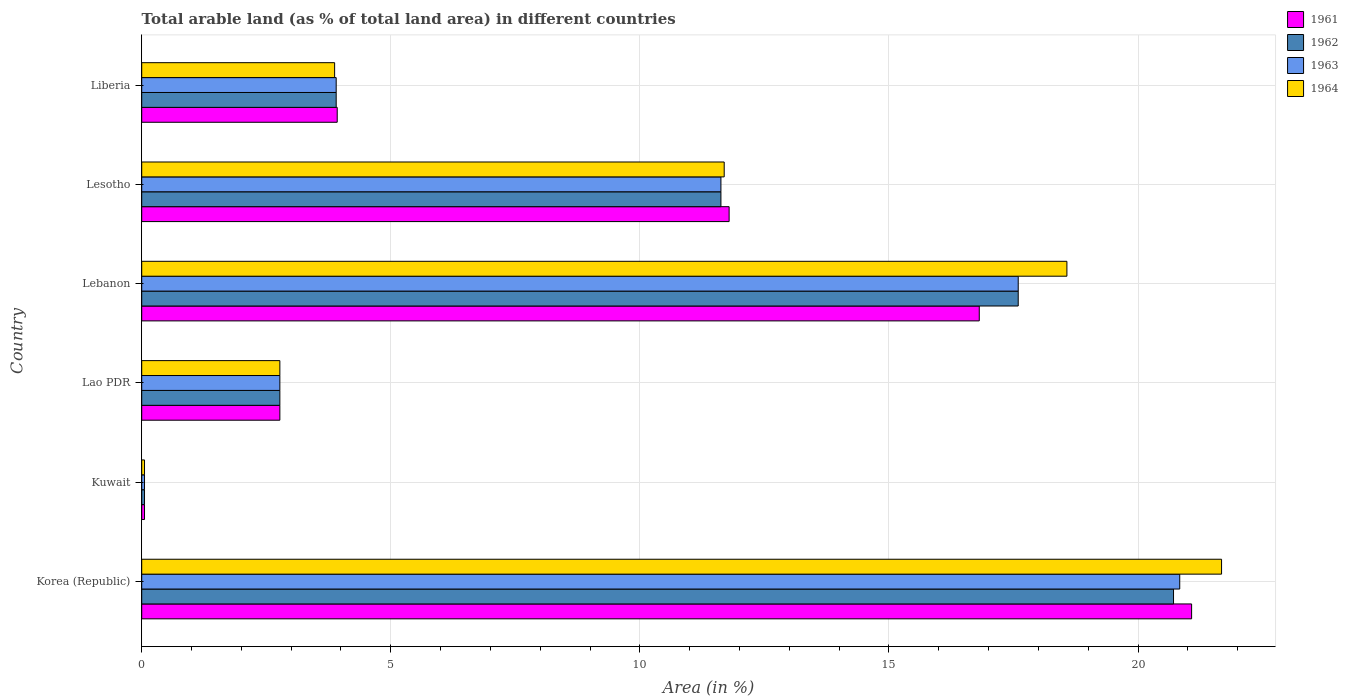How many different coloured bars are there?
Give a very brief answer. 4. How many groups of bars are there?
Give a very brief answer. 6. Are the number of bars per tick equal to the number of legend labels?
Keep it short and to the point. Yes. How many bars are there on the 4th tick from the top?
Your answer should be very brief. 4. What is the label of the 1st group of bars from the top?
Ensure brevity in your answer.  Liberia. What is the percentage of arable land in 1963 in Lao PDR?
Provide a succinct answer. 2.77. Across all countries, what is the maximum percentage of arable land in 1963?
Your answer should be very brief. 20.84. Across all countries, what is the minimum percentage of arable land in 1961?
Give a very brief answer. 0.06. In which country was the percentage of arable land in 1964 maximum?
Provide a succinct answer. Korea (Republic). In which country was the percentage of arable land in 1962 minimum?
Give a very brief answer. Kuwait. What is the total percentage of arable land in 1961 in the graph?
Your response must be concise. 56.43. What is the difference between the percentage of arable land in 1962 in Korea (Republic) and that in Kuwait?
Ensure brevity in your answer.  20.66. What is the difference between the percentage of arable land in 1961 in Kuwait and the percentage of arable land in 1964 in Korea (Republic)?
Make the answer very short. -21.62. What is the average percentage of arable land in 1963 per country?
Provide a succinct answer. 9.47. What is the difference between the percentage of arable land in 1963 and percentage of arable land in 1964 in Liberia?
Offer a very short reply. 0.03. In how many countries, is the percentage of arable land in 1963 greater than 15 %?
Offer a terse response. 2. What is the ratio of the percentage of arable land in 1963 in Lao PDR to that in Lebanon?
Your answer should be very brief. 0.16. Is the percentage of arable land in 1963 in Lao PDR less than that in Lebanon?
Provide a succinct answer. Yes. What is the difference between the highest and the second highest percentage of arable land in 1963?
Offer a very short reply. 3.24. What is the difference between the highest and the lowest percentage of arable land in 1964?
Provide a succinct answer. 21.62. Is the sum of the percentage of arable land in 1963 in Korea (Republic) and Liberia greater than the maximum percentage of arable land in 1964 across all countries?
Your answer should be very brief. Yes. What does the 1st bar from the top in Lebanon represents?
Make the answer very short. 1964. What does the 3rd bar from the bottom in Korea (Republic) represents?
Your answer should be compact. 1963. How many bars are there?
Offer a very short reply. 24. What is the title of the graph?
Provide a succinct answer. Total arable land (as % of total land area) in different countries. Does "1960" appear as one of the legend labels in the graph?
Your response must be concise. No. What is the label or title of the X-axis?
Your answer should be compact. Area (in %). What is the label or title of the Y-axis?
Ensure brevity in your answer.  Country. What is the Area (in %) of 1961 in Korea (Republic)?
Keep it short and to the point. 21.08. What is the Area (in %) in 1962 in Korea (Republic)?
Provide a short and direct response. 20.71. What is the Area (in %) in 1963 in Korea (Republic)?
Offer a very short reply. 20.84. What is the Area (in %) in 1964 in Korea (Republic)?
Your response must be concise. 21.68. What is the Area (in %) in 1961 in Kuwait?
Your answer should be compact. 0.06. What is the Area (in %) in 1962 in Kuwait?
Make the answer very short. 0.06. What is the Area (in %) of 1963 in Kuwait?
Offer a very short reply. 0.06. What is the Area (in %) in 1964 in Kuwait?
Provide a short and direct response. 0.06. What is the Area (in %) in 1961 in Lao PDR?
Your answer should be very brief. 2.77. What is the Area (in %) of 1962 in Lao PDR?
Offer a very short reply. 2.77. What is the Area (in %) in 1963 in Lao PDR?
Your response must be concise. 2.77. What is the Area (in %) in 1964 in Lao PDR?
Give a very brief answer. 2.77. What is the Area (in %) of 1961 in Lebanon?
Your answer should be compact. 16.81. What is the Area (in %) in 1962 in Lebanon?
Ensure brevity in your answer.  17.6. What is the Area (in %) in 1963 in Lebanon?
Provide a succinct answer. 17.6. What is the Area (in %) of 1964 in Lebanon?
Provide a short and direct response. 18.57. What is the Area (in %) of 1961 in Lesotho?
Make the answer very short. 11.79. What is the Area (in %) in 1962 in Lesotho?
Ensure brevity in your answer.  11.63. What is the Area (in %) in 1963 in Lesotho?
Offer a very short reply. 11.63. What is the Area (in %) in 1964 in Lesotho?
Offer a very short reply. 11.69. What is the Area (in %) of 1961 in Liberia?
Your response must be concise. 3.92. What is the Area (in %) in 1962 in Liberia?
Ensure brevity in your answer.  3.9. What is the Area (in %) of 1963 in Liberia?
Make the answer very short. 3.9. What is the Area (in %) of 1964 in Liberia?
Provide a succinct answer. 3.87. Across all countries, what is the maximum Area (in %) of 1961?
Give a very brief answer. 21.08. Across all countries, what is the maximum Area (in %) in 1962?
Give a very brief answer. 20.71. Across all countries, what is the maximum Area (in %) of 1963?
Provide a succinct answer. 20.84. Across all countries, what is the maximum Area (in %) of 1964?
Offer a terse response. 21.68. Across all countries, what is the minimum Area (in %) in 1961?
Give a very brief answer. 0.06. Across all countries, what is the minimum Area (in %) of 1962?
Provide a succinct answer. 0.06. Across all countries, what is the minimum Area (in %) in 1963?
Your answer should be very brief. 0.06. Across all countries, what is the minimum Area (in %) of 1964?
Your answer should be very brief. 0.06. What is the total Area (in %) in 1961 in the graph?
Give a very brief answer. 56.43. What is the total Area (in %) in 1962 in the graph?
Make the answer very short. 56.67. What is the total Area (in %) in 1963 in the graph?
Your answer should be compact. 56.79. What is the total Area (in %) in 1964 in the graph?
Provide a short and direct response. 58.64. What is the difference between the Area (in %) of 1961 in Korea (Republic) and that in Kuwait?
Give a very brief answer. 21.02. What is the difference between the Area (in %) of 1962 in Korea (Republic) and that in Kuwait?
Offer a very short reply. 20.66. What is the difference between the Area (in %) in 1963 in Korea (Republic) and that in Kuwait?
Your answer should be compact. 20.78. What is the difference between the Area (in %) of 1964 in Korea (Republic) and that in Kuwait?
Offer a terse response. 21.62. What is the difference between the Area (in %) in 1961 in Korea (Republic) and that in Lao PDR?
Offer a terse response. 18.3. What is the difference between the Area (in %) of 1962 in Korea (Republic) and that in Lao PDR?
Your response must be concise. 17.94. What is the difference between the Area (in %) in 1963 in Korea (Republic) and that in Lao PDR?
Offer a very short reply. 18.06. What is the difference between the Area (in %) of 1964 in Korea (Republic) and that in Lao PDR?
Ensure brevity in your answer.  18.9. What is the difference between the Area (in %) in 1961 in Korea (Republic) and that in Lebanon?
Provide a succinct answer. 4.26. What is the difference between the Area (in %) in 1962 in Korea (Republic) and that in Lebanon?
Offer a terse response. 3.12. What is the difference between the Area (in %) of 1963 in Korea (Republic) and that in Lebanon?
Your answer should be very brief. 3.24. What is the difference between the Area (in %) in 1964 in Korea (Republic) and that in Lebanon?
Provide a short and direct response. 3.1. What is the difference between the Area (in %) in 1961 in Korea (Republic) and that in Lesotho?
Your answer should be compact. 9.28. What is the difference between the Area (in %) of 1962 in Korea (Republic) and that in Lesotho?
Your response must be concise. 9.09. What is the difference between the Area (in %) of 1963 in Korea (Republic) and that in Lesotho?
Your answer should be very brief. 9.21. What is the difference between the Area (in %) of 1964 in Korea (Republic) and that in Lesotho?
Provide a short and direct response. 9.98. What is the difference between the Area (in %) in 1961 in Korea (Republic) and that in Liberia?
Provide a succinct answer. 17.15. What is the difference between the Area (in %) in 1962 in Korea (Republic) and that in Liberia?
Provide a short and direct response. 16.81. What is the difference between the Area (in %) of 1963 in Korea (Republic) and that in Liberia?
Provide a short and direct response. 16.93. What is the difference between the Area (in %) of 1964 in Korea (Republic) and that in Liberia?
Ensure brevity in your answer.  17.8. What is the difference between the Area (in %) in 1961 in Kuwait and that in Lao PDR?
Your response must be concise. -2.72. What is the difference between the Area (in %) in 1962 in Kuwait and that in Lao PDR?
Provide a short and direct response. -2.72. What is the difference between the Area (in %) of 1963 in Kuwait and that in Lao PDR?
Your response must be concise. -2.72. What is the difference between the Area (in %) of 1964 in Kuwait and that in Lao PDR?
Your answer should be compact. -2.72. What is the difference between the Area (in %) of 1961 in Kuwait and that in Lebanon?
Keep it short and to the point. -16.76. What is the difference between the Area (in %) of 1962 in Kuwait and that in Lebanon?
Offer a terse response. -17.54. What is the difference between the Area (in %) in 1963 in Kuwait and that in Lebanon?
Give a very brief answer. -17.54. What is the difference between the Area (in %) in 1964 in Kuwait and that in Lebanon?
Make the answer very short. -18.52. What is the difference between the Area (in %) in 1961 in Kuwait and that in Lesotho?
Your response must be concise. -11.74. What is the difference between the Area (in %) of 1962 in Kuwait and that in Lesotho?
Ensure brevity in your answer.  -11.57. What is the difference between the Area (in %) in 1963 in Kuwait and that in Lesotho?
Offer a very short reply. -11.57. What is the difference between the Area (in %) in 1964 in Kuwait and that in Lesotho?
Ensure brevity in your answer.  -11.64. What is the difference between the Area (in %) in 1961 in Kuwait and that in Liberia?
Make the answer very short. -3.87. What is the difference between the Area (in %) in 1962 in Kuwait and that in Liberia?
Offer a terse response. -3.85. What is the difference between the Area (in %) of 1963 in Kuwait and that in Liberia?
Provide a short and direct response. -3.85. What is the difference between the Area (in %) in 1964 in Kuwait and that in Liberia?
Give a very brief answer. -3.82. What is the difference between the Area (in %) of 1961 in Lao PDR and that in Lebanon?
Your answer should be very brief. -14.04. What is the difference between the Area (in %) in 1962 in Lao PDR and that in Lebanon?
Offer a terse response. -14.82. What is the difference between the Area (in %) in 1963 in Lao PDR and that in Lebanon?
Provide a succinct answer. -14.82. What is the difference between the Area (in %) in 1964 in Lao PDR and that in Lebanon?
Offer a terse response. -15.8. What is the difference between the Area (in %) in 1961 in Lao PDR and that in Lesotho?
Offer a very short reply. -9.02. What is the difference between the Area (in %) in 1962 in Lao PDR and that in Lesotho?
Offer a terse response. -8.85. What is the difference between the Area (in %) of 1963 in Lao PDR and that in Lesotho?
Give a very brief answer. -8.85. What is the difference between the Area (in %) in 1964 in Lao PDR and that in Lesotho?
Your answer should be compact. -8.92. What is the difference between the Area (in %) in 1961 in Lao PDR and that in Liberia?
Give a very brief answer. -1.15. What is the difference between the Area (in %) in 1962 in Lao PDR and that in Liberia?
Make the answer very short. -1.13. What is the difference between the Area (in %) of 1963 in Lao PDR and that in Liberia?
Your response must be concise. -1.13. What is the difference between the Area (in %) of 1964 in Lao PDR and that in Liberia?
Keep it short and to the point. -1.1. What is the difference between the Area (in %) of 1961 in Lebanon and that in Lesotho?
Provide a succinct answer. 5.02. What is the difference between the Area (in %) in 1962 in Lebanon and that in Lesotho?
Offer a very short reply. 5.97. What is the difference between the Area (in %) in 1963 in Lebanon and that in Lesotho?
Offer a very short reply. 5.97. What is the difference between the Area (in %) in 1964 in Lebanon and that in Lesotho?
Give a very brief answer. 6.88. What is the difference between the Area (in %) of 1961 in Lebanon and that in Liberia?
Make the answer very short. 12.89. What is the difference between the Area (in %) in 1962 in Lebanon and that in Liberia?
Your answer should be compact. 13.69. What is the difference between the Area (in %) of 1963 in Lebanon and that in Liberia?
Provide a short and direct response. 13.69. What is the difference between the Area (in %) of 1964 in Lebanon and that in Liberia?
Your response must be concise. 14.7. What is the difference between the Area (in %) of 1961 in Lesotho and that in Liberia?
Offer a very short reply. 7.87. What is the difference between the Area (in %) in 1962 in Lesotho and that in Liberia?
Provide a short and direct response. 7.72. What is the difference between the Area (in %) in 1963 in Lesotho and that in Liberia?
Keep it short and to the point. 7.72. What is the difference between the Area (in %) in 1964 in Lesotho and that in Liberia?
Provide a succinct answer. 7.82. What is the difference between the Area (in %) of 1961 in Korea (Republic) and the Area (in %) of 1962 in Kuwait?
Offer a terse response. 21.02. What is the difference between the Area (in %) of 1961 in Korea (Republic) and the Area (in %) of 1963 in Kuwait?
Give a very brief answer. 21.02. What is the difference between the Area (in %) of 1961 in Korea (Republic) and the Area (in %) of 1964 in Kuwait?
Offer a very short reply. 21.02. What is the difference between the Area (in %) of 1962 in Korea (Republic) and the Area (in %) of 1963 in Kuwait?
Keep it short and to the point. 20.66. What is the difference between the Area (in %) of 1962 in Korea (Republic) and the Area (in %) of 1964 in Kuwait?
Offer a very short reply. 20.66. What is the difference between the Area (in %) of 1963 in Korea (Republic) and the Area (in %) of 1964 in Kuwait?
Keep it short and to the point. 20.78. What is the difference between the Area (in %) of 1961 in Korea (Republic) and the Area (in %) of 1962 in Lao PDR?
Offer a terse response. 18.3. What is the difference between the Area (in %) in 1961 in Korea (Republic) and the Area (in %) in 1963 in Lao PDR?
Offer a terse response. 18.3. What is the difference between the Area (in %) in 1961 in Korea (Republic) and the Area (in %) in 1964 in Lao PDR?
Make the answer very short. 18.3. What is the difference between the Area (in %) of 1962 in Korea (Republic) and the Area (in %) of 1963 in Lao PDR?
Provide a short and direct response. 17.94. What is the difference between the Area (in %) in 1962 in Korea (Republic) and the Area (in %) in 1964 in Lao PDR?
Provide a succinct answer. 17.94. What is the difference between the Area (in %) of 1963 in Korea (Republic) and the Area (in %) of 1964 in Lao PDR?
Make the answer very short. 18.06. What is the difference between the Area (in %) of 1961 in Korea (Republic) and the Area (in %) of 1962 in Lebanon?
Keep it short and to the point. 3.48. What is the difference between the Area (in %) in 1961 in Korea (Republic) and the Area (in %) in 1963 in Lebanon?
Provide a succinct answer. 3.48. What is the difference between the Area (in %) of 1961 in Korea (Republic) and the Area (in %) of 1964 in Lebanon?
Keep it short and to the point. 2.5. What is the difference between the Area (in %) of 1962 in Korea (Republic) and the Area (in %) of 1963 in Lebanon?
Give a very brief answer. 3.12. What is the difference between the Area (in %) in 1962 in Korea (Republic) and the Area (in %) in 1964 in Lebanon?
Make the answer very short. 2.14. What is the difference between the Area (in %) of 1963 in Korea (Republic) and the Area (in %) of 1964 in Lebanon?
Make the answer very short. 2.26. What is the difference between the Area (in %) in 1961 in Korea (Republic) and the Area (in %) in 1962 in Lesotho?
Keep it short and to the point. 9.45. What is the difference between the Area (in %) in 1961 in Korea (Republic) and the Area (in %) in 1963 in Lesotho?
Offer a very short reply. 9.45. What is the difference between the Area (in %) in 1961 in Korea (Republic) and the Area (in %) in 1964 in Lesotho?
Provide a short and direct response. 9.38. What is the difference between the Area (in %) of 1962 in Korea (Republic) and the Area (in %) of 1963 in Lesotho?
Your answer should be compact. 9.09. What is the difference between the Area (in %) in 1962 in Korea (Republic) and the Area (in %) in 1964 in Lesotho?
Give a very brief answer. 9.02. What is the difference between the Area (in %) of 1963 in Korea (Republic) and the Area (in %) of 1964 in Lesotho?
Your answer should be compact. 9.14. What is the difference between the Area (in %) of 1961 in Korea (Republic) and the Area (in %) of 1962 in Liberia?
Offer a terse response. 17.17. What is the difference between the Area (in %) in 1961 in Korea (Republic) and the Area (in %) in 1963 in Liberia?
Ensure brevity in your answer.  17.17. What is the difference between the Area (in %) of 1961 in Korea (Republic) and the Area (in %) of 1964 in Liberia?
Offer a terse response. 17.2. What is the difference between the Area (in %) of 1962 in Korea (Republic) and the Area (in %) of 1963 in Liberia?
Keep it short and to the point. 16.81. What is the difference between the Area (in %) of 1962 in Korea (Republic) and the Area (in %) of 1964 in Liberia?
Make the answer very short. 16.84. What is the difference between the Area (in %) of 1963 in Korea (Republic) and the Area (in %) of 1964 in Liberia?
Offer a terse response. 16.97. What is the difference between the Area (in %) of 1961 in Kuwait and the Area (in %) of 1962 in Lao PDR?
Keep it short and to the point. -2.72. What is the difference between the Area (in %) of 1961 in Kuwait and the Area (in %) of 1963 in Lao PDR?
Offer a terse response. -2.72. What is the difference between the Area (in %) in 1961 in Kuwait and the Area (in %) in 1964 in Lao PDR?
Give a very brief answer. -2.72. What is the difference between the Area (in %) in 1962 in Kuwait and the Area (in %) in 1963 in Lao PDR?
Provide a succinct answer. -2.72. What is the difference between the Area (in %) of 1962 in Kuwait and the Area (in %) of 1964 in Lao PDR?
Your answer should be compact. -2.72. What is the difference between the Area (in %) of 1963 in Kuwait and the Area (in %) of 1964 in Lao PDR?
Your answer should be compact. -2.72. What is the difference between the Area (in %) in 1961 in Kuwait and the Area (in %) in 1962 in Lebanon?
Make the answer very short. -17.54. What is the difference between the Area (in %) of 1961 in Kuwait and the Area (in %) of 1963 in Lebanon?
Offer a terse response. -17.54. What is the difference between the Area (in %) of 1961 in Kuwait and the Area (in %) of 1964 in Lebanon?
Your response must be concise. -18.52. What is the difference between the Area (in %) in 1962 in Kuwait and the Area (in %) in 1963 in Lebanon?
Your answer should be compact. -17.54. What is the difference between the Area (in %) in 1962 in Kuwait and the Area (in %) in 1964 in Lebanon?
Your answer should be very brief. -18.52. What is the difference between the Area (in %) of 1963 in Kuwait and the Area (in %) of 1964 in Lebanon?
Ensure brevity in your answer.  -18.52. What is the difference between the Area (in %) in 1961 in Kuwait and the Area (in %) in 1962 in Lesotho?
Offer a very short reply. -11.57. What is the difference between the Area (in %) in 1961 in Kuwait and the Area (in %) in 1963 in Lesotho?
Give a very brief answer. -11.57. What is the difference between the Area (in %) of 1961 in Kuwait and the Area (in %) of 1964 in Lesotho?
Offer a terse response. -11.64. What is the difference between the Area (in %) of 1962 in Kuwait and the Area (in %) of 1963 in Lesotho?
Provide a short and direct response. -11.57. What is the difference between the Area (in %) in 1962 in Kuwait and the Area (in %) in 1964 in Lesotho?
Give a very brief answer. -11.64. What is the difference between the Area (in %) of 1963 in Kuwait and the Area (in %) of 1964 in Lesotho?
Your answer should be very brief. -11.64. What is the difference between the Area (in %) of 1961 in Kuwait and the Area (in %) of 1962 in Liberia?
Your response must be concise. -3.85. What is the difference between the Area (in %) in 1961 in Kuwait and the Area (in %) in 1963 in Liberia?
Offer a terse response. -3.85. What is the difference between the Area (in %) of 1961 in Kuwait and the Area (in %) of 1964 in Liberia?
Your answer should be compact. -3.82. What is the difference between the Area (in %) of 1962 in Kuwait and the Area (in %) of 1963 in Liberia?
Your response must be concise. -3.85. What is the difference between the Area (in %) in 1962 in Kuwait and the Area (in %) in 1964 in Liberia?
Offer a very short reply. -3.82. What is the difference between the Area (in %) of 1963 in Kuwait and the Area (in %) of 1964 in Liberia?
Offer a very short reply. -3.82. What is the difference between the Area (in %) of 1961 in Lao PDR and the Area (in %) of 1962 in Lebanon?
Give a very brief answer. -14.82. What is the difference between the Area (in %) in 1961 in Lao PDR and the Area (in %) in 1963 in Lebanon?
Provide a short and direct response. -14.82. What is the difference between the Area (in %) of 1961 in Lao PDR and the Area (in %) of 1964 in Lebanon?
Your response must be concise. -15.8. What is the difference between the Area (in %) of 1962 in Lao PDR and the Area (in %) of 1963 in Lebanon?
Your answer should be very brief. -14.82. What is the difference between the Area (in %) of 1962 in Lao PDR and the Area (in %) of 1964 in Lebanon?
Provide a succinct answer. -15.8. What is the difference between the Area (in %) in 1963 in Lao PDR and the Area (in %) in 1964 in Lebanon?
Keep it short and to the point. -15.8. What is the difference between the Area (in %) in 1961 in Lao PDR and the Area (in %) in 1962 in Lesotho?
Offer a terse response. -8.85. What is the difference between the Area (in %) in 1961 in Lao PDR and the Area (in %) in 1963 in Lesotho?
Your answer should be very brief. -8.85. What is the difference between the Area (in %) of 1961 in Lao PDR and the Area (in %) of 1964 in Lesotho?
Offer a terse response. -8.92. What is the difference between the Area (in %) in 1962 in Lao PDR and the Area (in %) in 1963 in Lesotho?
Your answer should be very brief. -8.85. What is the difference between the Area (in %) in 1962 in Lao PDR and the Area (in %) in 1964 in Lesotho?
Keep it short and to the point. -8.92. What is the difference between the Area (in %) in 1963 in Lao PDR and the Area (in %) in 1964 in Lesotho?
Give a very brief answer. -8.92. What is the difference between the Area (in %) of 1961 in Lao PDR and the Area (in %) of 1962 in Liberia?
Provide a short and direct response. -1.13. What is the difference between the Area (in %) of 1961 in Lao PDR and the Area (in %) of 1963 in Liberia?
Your response must be concise. -1.13. What is the difference between the Area (in %) in 1961 in Lao PDR and the Area (in %) in 1964 in Liberia?
Make the answer very short. -1.1. What is the difference between the Area (in %) in 1962 in Lao PDR and the Area (in %) in 1963 in Liberia?
Make the answer very short. -1.13. What is the difference between the Area (in %) in 1962 in Lao PDR and the Area (in %) in 1964 in Liberia?
Provide a short and direct response. -1.1. What is the difference between the Area (in %) of 1963 in Lao PDR and the Area (in %) of 1964 in Liberia?
Make the answer very short. -1.1. What is the difference between the Area (in %) of 1961 in Lebanon and the Area (in %) of 1962 in Lesotho?
Provide a short and direct response. 5.19. What is the difference between the Area (in %) of 1961 in Lebanon and the Area (in %) of 1963 in Lesotho?
Ensure brevity in your answer.  5.19. What is the difference between the Area (in %) of 1961 in Lebanon and the Area (in %) of 1964 in Lesotho?
Your response must be concise. 5.12. What is the difference between the Area (in %) in 1962 in Lebanon and the Area (in %) in 1963 in Lesotho?
Provide a succinct answer. 5.97. What is the difference between the Area (in %) of 1962 in Lebanon and the Area (in %) of 1964 in Lesotho?
Ensure brevity in your answer.  5.9. What is the difference between the Area (in %) in 1963 in Lebanon and the Area (in %) in 1964 in Lesotho?
Offer a very short reply. 5.9. What is the difference between the Area (in %) of 1961 in Lebanon and the Area (in %) of 1962 in Liberia?
Offer a terse response. 12.91. What is the difference between the Area (in %) of 1961 in Lebanon and the Area (in %) of 1963 in Liberia?
Make the answer very short. 12.91. What is the difference between the Area (in %) of 1961 in Lebanon and the Area (in %) of 1964 in Liberia?
Provide a succinct answer. 12.94. What is the difference between the Area (in %) in 1962 in Lebanon and the Area (in %) in 1963 in Liberia?
Offer a terse response. 13.69. What is the difference between the Area (in %) of 1962 in Lebanon and the Area (in %) of 1964 in Liberia?
Provide a succinct answer. 13.72. What is the difference between the Area (in %) of 1963 in Lebanon and the Area (in %) of 1964 in Liberia?
Give a very brief answer. 13.72. What is the difference between the Area (in %) in 1961 in Lesotho and the Area (in %) in 1962 in Liberia?
Ensure brevity in your answer.  7.89. What is the difference between the Area (in %) in 1961 in Lesotho and the Area (in %) in 1963 in Liberia?
Offer a very short reply. 7.89. What is the difference between the Area (in %) of 1961 in Lesotho and the Area (in %) of 1964 in Liberia?
Keep it short and to the point. 7.92. What is the difference between the Area (in %) of 1962 in Lesotho and the Area (in %) of 1963 in Liberia?
Your answer should be compact. 7.72. What is the difference between the Area (in %) of 1962 in Lesotho and the Area (in %) of 1964 in Liberia?
Make the answer very short. 7.75. What is the difference between the Area (in %) in 1963 in Lesotho and the Area (in %) in 1964 in Liberia?
Offer a very short reply. 7.75. What is the average Area (in %) of 1961 per country?
Your response must be concise. 9.41. What is the average Area (in %) of 1962 per country?
Your answer should be compact. 9.44. What is the average Area (in %) of 1963 per country?
Provide a succinct answer. 9.47. What is the average Area (in %) in 1964 per country?
Provide a short and direct response. 9.77. What is the difference between the Area (in %) in 1961 and Area (in %) in 1962 in Korea (Republic)?
Provide a short and direct response. 0.36. What is the difference between the Area (in %) of 1961 and Area (in %) of 1963 in Korea (Republic)?
Your answer should be very brief. 0.24. What is the difference between the Area (in %) of 1961 and Area (in %) of 1964 in Korea (Republic)?
Offer a very short reply. -0.6. What is the difference between the Area (in %) of 1962 and Area (in %) of 1963 in Korea (Republic)?
Provide a succinct answer. -0.12. What is the difference between the Area (in %) of 1962 and Area (in %) of 1964 in Korea (Republic)?
Your answer should be very brief. -0.96. What is the difference between the Area (in %) in 1963 and Area (in %) in 1964 in Korea (Republic)?
Provide a succinct answer. -0.84. What is the difference between the Area (in %) in 1961 and Area (in %) in 1962 in Kuwait?
Your answer should be very brief. 0. What is the difference between the Area (in %) in 1961 and Area (in %) in 1963 in Kuwait?
Make the answer very short. 0. What is the difference between the Area (in %) of 1961 and Area (in %) of 1964 in Kuwait?
Your answer should be very brief. 0. What is the difference between the Area (in %) in 1962 and Area (in %) in 1963 in Kuwait?
Offer a terse response. 0. What is the difference between the Area (in %) of 1962 and Area (in %) of 1964 in Kuwait?
Keep it short and to the point. 0. What is the difference between the Area (in %) in 1961 and Area (in %) in 1963 in Lao PDR?
Give a very brief answer. 0. What is the difference between the Area (in %) in 1962 and Area (in %) in 1964 in Lao PDR?
Give a very brief answer. 0. What is the difference between the Area (in %) in 1963 and Area (in %) in 1964 in Lao PDR?
Ensure brevity in your answer.  0. What is the difference between the Area (in %) of 1961 and Area (in %) of 1962 in Lebanon?
Your response must be concise. -0.78. What is the difference between the Area (in %) of 1961 and Area (in %) of 1963 in Lebanon?
Give a very brief answer. -0.78. What is the difference between the Area (in %) of 1961 and Area (in %) of 1964 in Lebanon?
Offer a very short reply. -1.76. What is the difference between the Area (in %) in 1962 and Area (in %) in 1964 in Lebanon?
Offer a very short reply. -0.98. What is the difference between the Area (in %) in 1963 and Area (in %) in 1964 in Lebanon?
Provide a succinct answer. -0.98. What is the difference between the Area (in %) of 1961 and Area (in %) of 1962 in Lesotho?
Your response must be concise. 0.16. What is the difference between the Area (in %) in 1961 and Area (in %) in 1963 in Lesotho?
Your response must be concise. 0.16. What is the difference between the Area (in %) in 1961 and Area (in %) in 1964 in Lesotho?
Your response must be concise. 0.1. What is the difference between the Area (in %) of 1962 and Area (in %) of 1963 in Lesotho?
Your answer should be compact. 0. What is the difference between the Area (in %) in 1962 and Area (in %) in 1964 in Lesotho?
Offer a very short reply. -0.07. What is the difference between the Area (in %) of 1963 and Area (in %) of 1964 in Lesotho?
Your answer should be compact. -0.07. What is the difference between the Area (in %) of 1961 and Area (in %) of 1962 in Liberia?
Offer a very short reply. 0.02. What is the difference between the Area (in %) in 1961 and Area (in %) in 1963 in Liberia?
Ensure brevity in your answer.  0.02. What is the difference between the Area (in %) in 1961 and Area (in %) in 1964 in Liberia?
Offer a terse response. 0.05. What is the difference between the Area (in %) in 1962 and Area (in %) in 1963 in Liberia?
Your answer should be compact. 0. What is the difference between the Area (in %) of 1962 and Area (in %) of 1964 in Liberia?
Your answer should be very brief. 0.03. What is the difference between the Area (in %) of 1963 and Area (in %) of 1964 in Liberia?
Keep it short and to the point. 0.03. What is the ratio of the Area (in %) in 1961 in Korea (Republic) to that in Kuwait?
Your response must be concise. 375.58. What is the ratio of the Area (in %) in 1962 in Korea (Republic) to that in Kuwait?
Give a very brief answer. 369.11. What is the ratio of the Area (in %) of 1963 in Korea (Republic) to that in Kuwait?
Give a very brief answer. 371.33. What is the ratio of the Area (in %) of 1964 in Korea (Republic) to that in Kuwait?
Your answer should be very brief. 386.29. What is the ratio of the Area (in %) in 1961 in Korea (Republic) to that in Lao PDR?
Give a very brief answer. 7.6. What is the ratio of the Area (in %) of 1962 in Korea (Republic) to that in Lao PDR?
Provide a short and direct response. 7.47. What is the ratio of the Area (in %) in 1963 in Korea (Republic) to that in Lao PDR?
Provide a short and direct response. 7.51. What is the ratio of the Area (in %) of 1964 in Korea (Republic) to that in Lao PDR?
Provide a succinct answer. 7.82. What is the ratio of the Area (in %) of 1961 in Korea (Republic) to that in Lebanon?
Provide a succinct answer. 1.25. What is the ratio of the Area (in %) in 1962 in Korea (Republic) to that in Lebanon?
Provide a short and direct response. 1.18. What is the ratio of the Area (in %) of 1963 in Korea (Republic) to that in Lebanon?
Provide a succinct answer. 1.18. What is the ratio of the Area (in %) of 1964 in Korea (Republic) to that in Lebanon?
Offer a terse response. 1.17. What is the ratio of the Area (in %) of 1961 in Korea (Republic) to that in Lesotho?
Make the answer very short. 1.79. What is the ratio of the Area (in %) in 1962 in Korea (Republic) to that in Lesotho?
Give a very brief answer. 1.78. What is the ratio of the Area (in %) in 1963 in Korea (Republic) to that in Lesotho?
Make the answer very short. 1.79. What is the ratio of the Area (in %) of 1964 in Korea (Republic) to that in Lesotho?
Provide a short and direct response. 1.85. What is the ratio of the Area (in %) in 1961 in Korea (Republic) to that in Liberia?
Offer a very short reply. 5.37. What is the ratio of the Area (in %) in 1962 in Korea (Republic) to that in Liberia?
Your answer should be compact. 5.31. What is the ratio of the Area (in %) of 1963 in Korea (Republic) to that in Liberia?
Your answer should be compact. 5.34. What is the ratio of the Area (in %) of 1964 in Korea (Republic) to that in Liberia?
Offer a terse response. 5.6. What is the ratio of the Area (in %) of 1961 in Kuwait to that in Lao PDR?
Provide a succinct answer. 0.02. What is the ratio of the Area (in %) in 1962 in Kuwait to that in Lao PDR?
Provide a short and direct response. 0.02. What is the ratio of the Area (in %) in 1963 in Kuwait to that in Lao PDR?
Keep it short and to the point. 0.02. What is the ratio of the Area (in %) in 1964 in Kuwait to that in Lao PDR?
Your response must be concise. 0.02. What is the ratio of the Area (in %) in 1961 in Kuwait to that in Lebanon?
Offer a terse response. 0. What is the ratio of the Area (in %) of 1962 in Kuwait to that in Lebanon?
Provide a succinct answer. 0. What is the ratio of the Area (in %) of 1963 in Kuwait to that in Lebanon?
Ensure brevity in your answer.  0. What is the ratio of the Area (in %) of 1964 in Kuwait to that in Lebanon?
Keep it short and to the point. 0. What is the ratio of the Area (in %) in 1961 in Kuwait to that in Lesotho?
Ensure brevity in your answer.  0. What is the ratio of the Area (in %) of 1962 in Kuwait to that in Lesotho?
Offer a very short reply. 0. What is the ratio of the Area (in %) in 1963 in Kuwait to that in Lesotho?
Your response must be concise. 0. What is the ratio of the Area (in %) in 1964 in Kuwait to that in Lesotho?
Provide a short and direct response. 0. What is the ratio of the Area (in %) of 1961 in Kuwait to that in Liberia?
Provide a succinct answer. 0.01. What is the ratio of the Area (in %) in 1962 in Kuwait to that in Liberia?
Ensure brevity in your answer.  0.01. What is the ratio of the Area (in %) in 1963 in Kuwait to that in Liberia?
Offer a very short reply. 0.01. What is the ratio of the Area (in %) of 1964 in Kuwait to that in Liberia?
Your answer should be compact. 0.01. What is the ratio of the Area (in %) in 1961 in Lao PDR to that in Lebanon?
Offer a terse response. 0.16. What is the ratio of the Area (in %) of 1962 in Lao PDR to that in Lebanon?
Provide a succinct answer. 0.16. What is the ratio of the Area (in %) in 1963 in Lao PDR to that in Lebanon?
Make the answer very short. 0.16. What is the ratio of the Area (in %) in 1964 in Lao PDR to that in Lebanon?
Make the answer very short. 0.15. What is the ratio of the Area (in %) in 1961 in Lao PDR to that in Lesotho?
Your response must be concise. 0.24. What is the ratio of the Area (in %) in 1962 in Lao PDR to that in Lesotho?
Your response must be concise. 0.24. What is the ratio of the Area (in %) of 1963 in Lao PDR to that in Lesotho?
Make the answer very short. 0.24. What is the ratio of the Area (in %) in 1964 in Lao PDR to that in Lesotho?
Provide a short and direct response. 0.24. What is the ratio of the Area (in %) of 1961 in Lao PDR to that in Liberia?
Your response must be concise. 0.71. What is the ratio of the Area (in %) in 1962 in Lao PDR to that in Liberia?
Your response must be concise. 0.71. What is the ratio of the Area (in %) in 1963 in Lao PDR to that in Liberia?
Your answer should be very brief. 0.71. What is the ratio of the Area (in %) in 1964 in Lao PDR to that in Liberia?
Your response must be concise. 0.72. What is the ratio of the Area (in %) in 1961 in Lebanon to that in Lesotho?
Ensure brevity in your answer.  1.43. What is the ratio of the Area (in %) in 1962 in Lebanon to that in Lesotho?
Offer a very short reply. 1.51. What is the ratio of the Area (in %) of 1963 in Lebanon to that in Lesotho?
Keep it short and to the point. 1.51. What is the ratio of the Area (in %) in 1964 in Lebanon to that in Lesotho?
Offer a terse response. 1.59. What is the ratio of the Area (in %) in 1961 in Lebanon to that in Liberia?
Make the answer very short. 4.28. What is the ratio of the Area (in %) in 1962 in Lebanon to that in Liberia?
Offer a terse response. 4.51. What is the ratio of the Area (in %) in 1963 in Lebanon to that in Liberia?
Your answer should be compact. 4.51. What is the ratio of the Area (in %) in 1964 in Lebanon to that in Liberia?
Provide a succinct answer. 4.8. What is the ratio of the Area (in %) of 1961 in Lesotho to that in Liberia?
Provide a succinct answer. 3. What is the ratio of the Area (in %) of 1962 in Lesotho to that in Liberia?
Keep it short and to the point. 2.98. What is the ratio of the Area (in %) in 1963 in Lesotho to that in Liberia?
Provide a succinct answer. 2.98. What is the ratio of the Area (in %) of 1964 in Lesotho to that in Liberia?
Your response must be concise. 3.02. What is the difference between the highest and the second highest Area (in %) of 1961?
Your answer should be very brief. 4.26. What is the difference between the highest and the second highest Area (in %) in 1962?
Make the answer very short. 3.12. What is the difference between the highest and the second highest Area (in %) of 1963?
Give a very brief answer. 3.24. What is the difference between the highest and the second highest Area (in %) of 1964?
Ensure brevity in your answer.  3.1. What is the difference between the highest and the lowest Area (in %) of 1961?
Give a very brief answer. 21.02. What is the difference between the highest and the lowest Area (in %) of 1962?
Provide a short and direct response. 20.66. What is the difference between the highest and the lowest Area (in %) in 1963?
Provide a succinct answer. 20.78. What is the difference between the highest and the lowest Area (in %) in 1964?
Your answer should be compact. 21.62. 